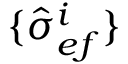Convert formula to latex. <formula><loc_0><loc_0><loc_500><loc_500>\{ \hat { \sigma } _ { e f } ^ { i } \}</formula> 